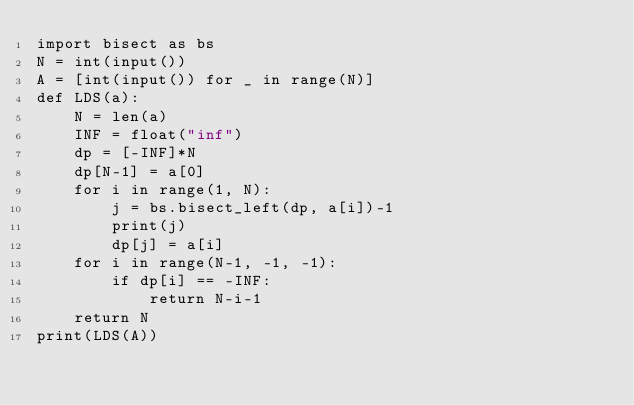<code> <loc_0><loc_0><loc_500><loc_500><_Python_>import bisect as bs
N = int(input())
A = [int(input()) for _ in range(N)]
def LDS(a):
    N = len(a)
    INF = float("inf")
    dp = [-INF]*N
    dp[N-1] = a[0]
    for i in range(1, N):
        j = bs.bisect_left(dp, a[i])-1
        print(j)
        dp[j] = a[i]
    for i in range(N-1, -1, -1):
        if dp[i] == -INF:
            return N-i-1
    return N
print(LDS(A))</code> 